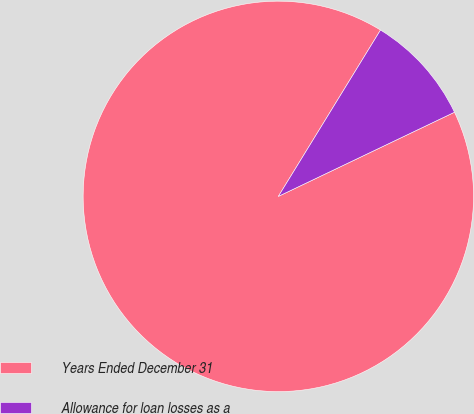Convert chart to OTSL. <chart><loc_0><loc_0><loc_500><loc_500><pie_chart><fcel>Years Ended December 31<fcel>Allowance for loan losses as a<nl><fcel>90.86%<fcel>9.14%<nl></chart> 